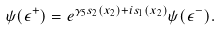Convert formula to latex. <formula><loc_0><loc_0><loc_500><loc_500>\psi ( { \epsilon } ^ { + } ) = e ^ { { \gamma } _ { 5 } s _ { 2 } ( x _ { 2 } ) + i s _ { 1 } ( x _ { 2 } ) } \psi ( { \epsilon } ^ { - } ) .</formula> 